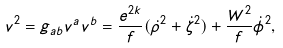Convert formula to latex. <formula><loc_0><loc_0><loc_500><loc_500>v ^ { 2 } = g _ { a b } v ^ { a } v ^ { b } = \frac { e ^ { 2 k } } { f } ( \dot { \rho } ^ { 2 } + \dot { \zeta } ^ { 2 } ) + \frac { W ^ { 2 } } { f } \dot { \phi } ^ { 2 } ,</formula> 